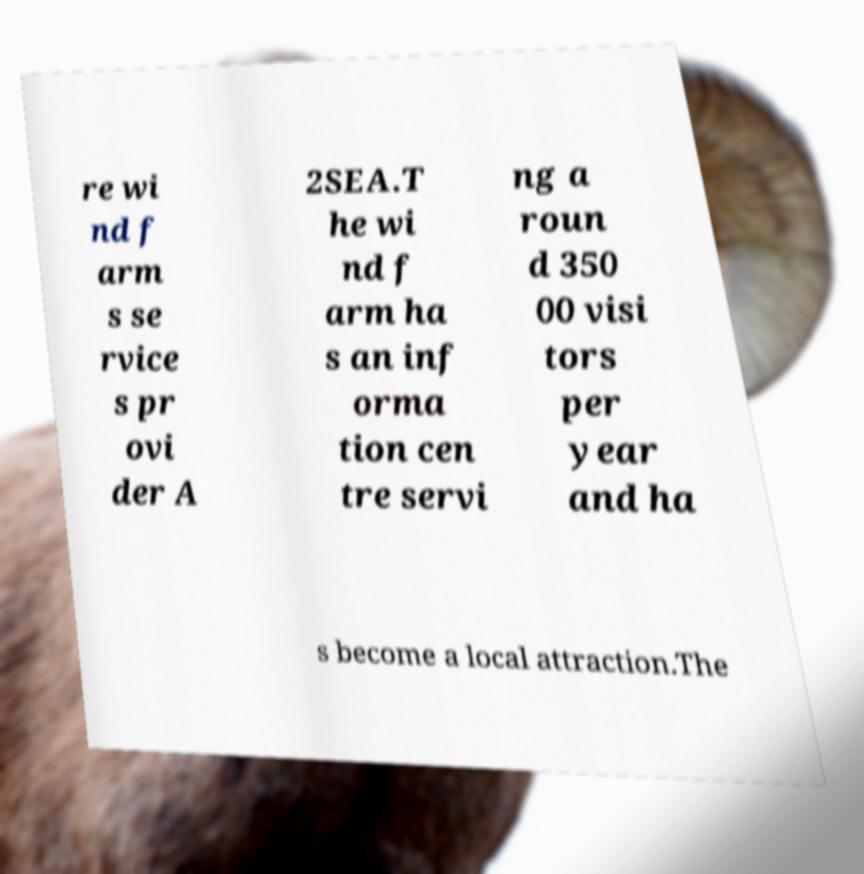What messages or text are displayed in this image? I need them in a readable, typed format. re wi nd f arm s se rvice s pr ovi der A 2SEA.T he wi nd f arm ha s an inf orma tion cen tre servi ng a roun d 350 00 visi tors per year and ha s become a local attraction.The 